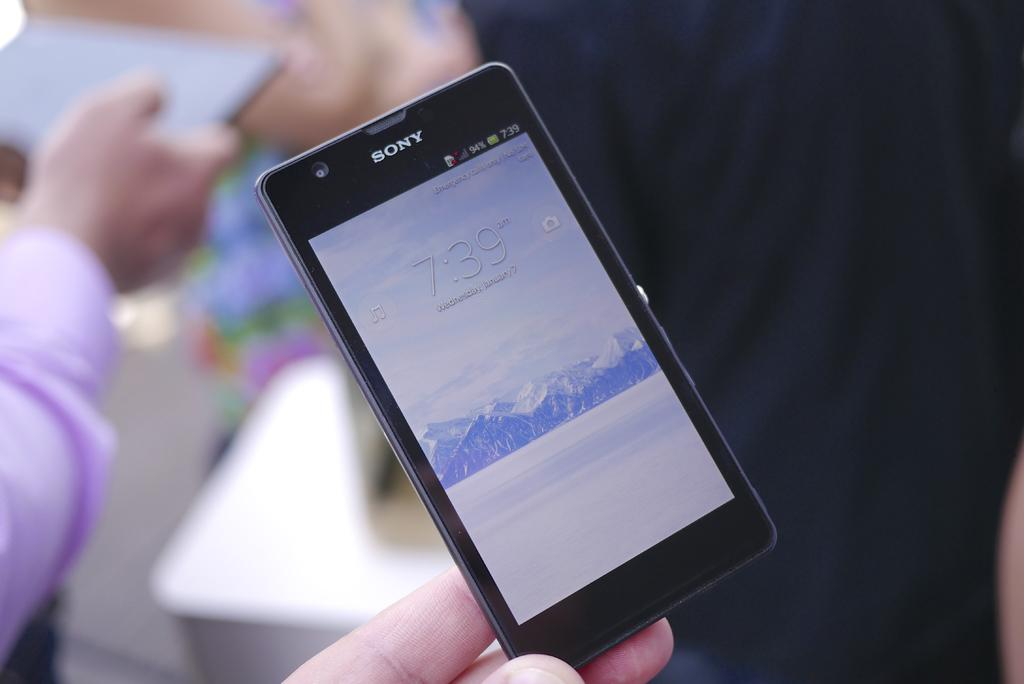<image>
Share a concise interpretation of the image provided. A person is holding a Sony cell phone in their left hand. 